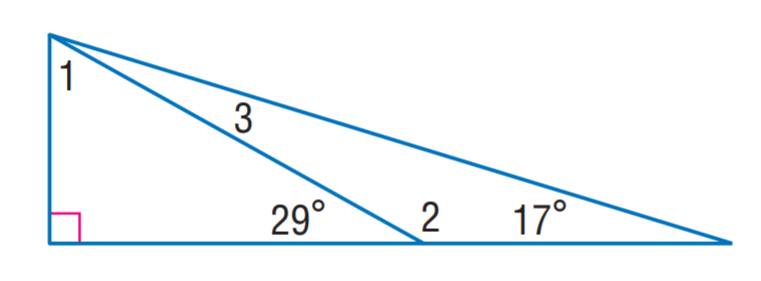Answer the mathemtical geometry problem and directly provide the correct option letter.
Question: Find m \angle 2.
Choices: A: 12 B: 61 C: 151 D: 163 C 